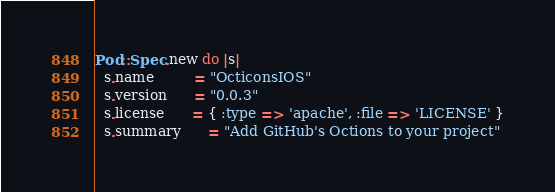Convert code to text. <code><loc_0><loc_0><loc_500><loc_500><_Ruby_>Pod::Spec.new do |s|
  s.name         = "OcticonsIOS"
  s.version      = "0.0.3"
  s.license      = { :type => 'apache', :file => 'LICENSE' }
  s.summary      = "Add GitHub's Octions to your project"</code> 